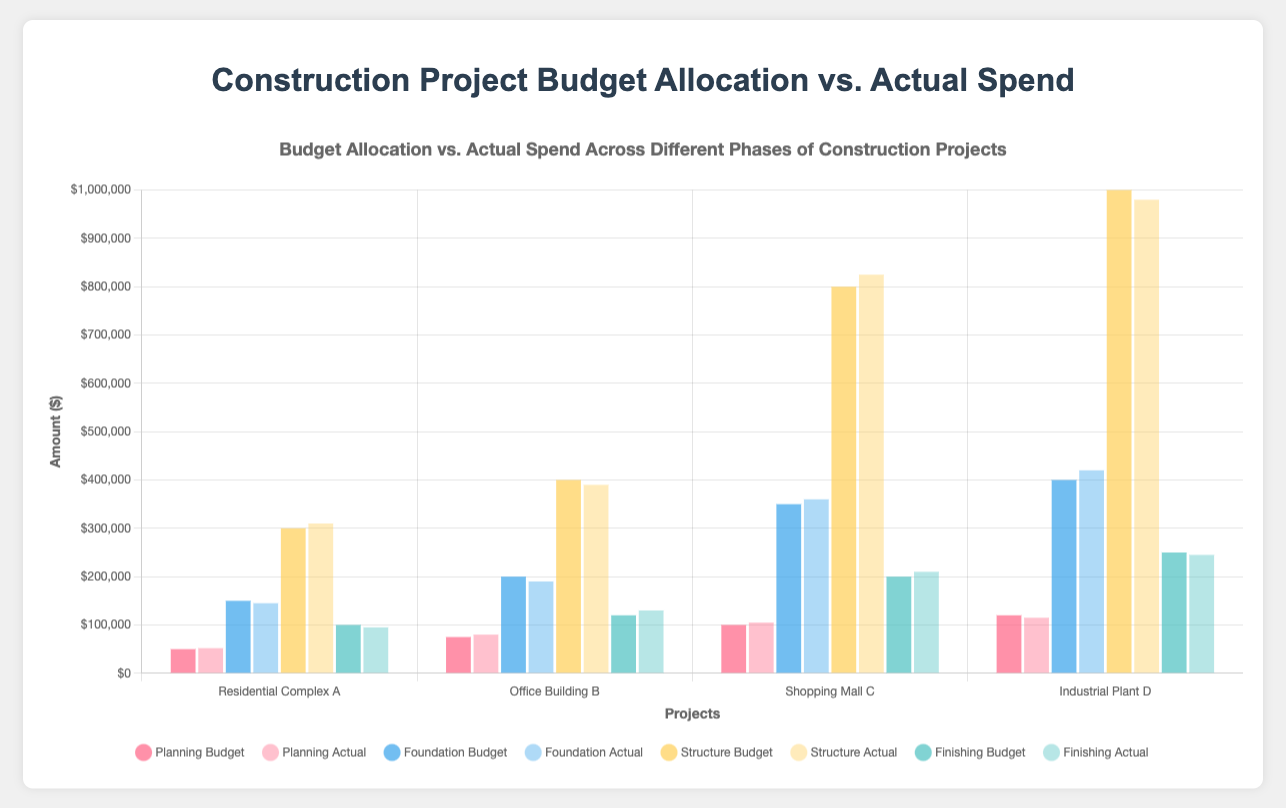Which phase had the largest overspend in Residential Complex A? By comparing the difference between the budget allocation and actual spend for each phase in Residential Complex A, we can see that the Structure phase had the largest overspend. The overspend is $310,000 (actual spend) - $300,000 (budget allocation) = $10,000.
Answer: Structure In Planning phase, which project had the highest actual spend? By comparing the actual spend in the Planning phase across all four projects, we see that "Industrial Plant D" had the highest actual spend at $115,000.
Answer: Industrial Plant D How much more was spent during the Finishing phase in Office Building B compared to Residential Complex A? By subtracting the actual spend of the Finishing phase in Residential Complex A from Office Building B, we get the difference. $130,000 (Office Building B) - $95,000 (Residential Complex A) = $35,000.
Answer: $35,000 For Shopping Mall C, what is the total amount spent across all phases? By summing the actual spends across all phases for Shopping Mall C: $105,000 (Planning) + $360,000 (Foundation) + $825,000 (Structure) + $210,000 (Finishing) = $1,500,000.
Answer: $1,500,000 Did any projects stay under budget for all phases? By checking each phase's actual spend against its budget allocation for all projects, we see that none of the projects stayed under budget for all phases.
Answer: No Which phase in Industrial Plant D had the least amount of overspend or underspend? By calculating the difference between budget allocation and actual spend for each phase in Industrial Plant D, the Finishing phase had the smallest difference: $250,000 (budget allocation) - $245,000 (actual spend) = $5,000.
Answer: Finishing What is the average budget allocation for the Planning phase across all projects? By summing the budget allocations for the Planning phase across all projects and dividing by the number of projects: ($50,000 + $75,000 + $100,000 + $120,000) / 4 = $86,250.
Answer: $86,250 Among all projects, which one had the highest budget allocation for the Structure phase? By comparing the budget allocation for the Structure phase across all projects, "Industrial Plant D" had the highest budget allocation at $1,000,000.
Answer: Industrial Plant D 